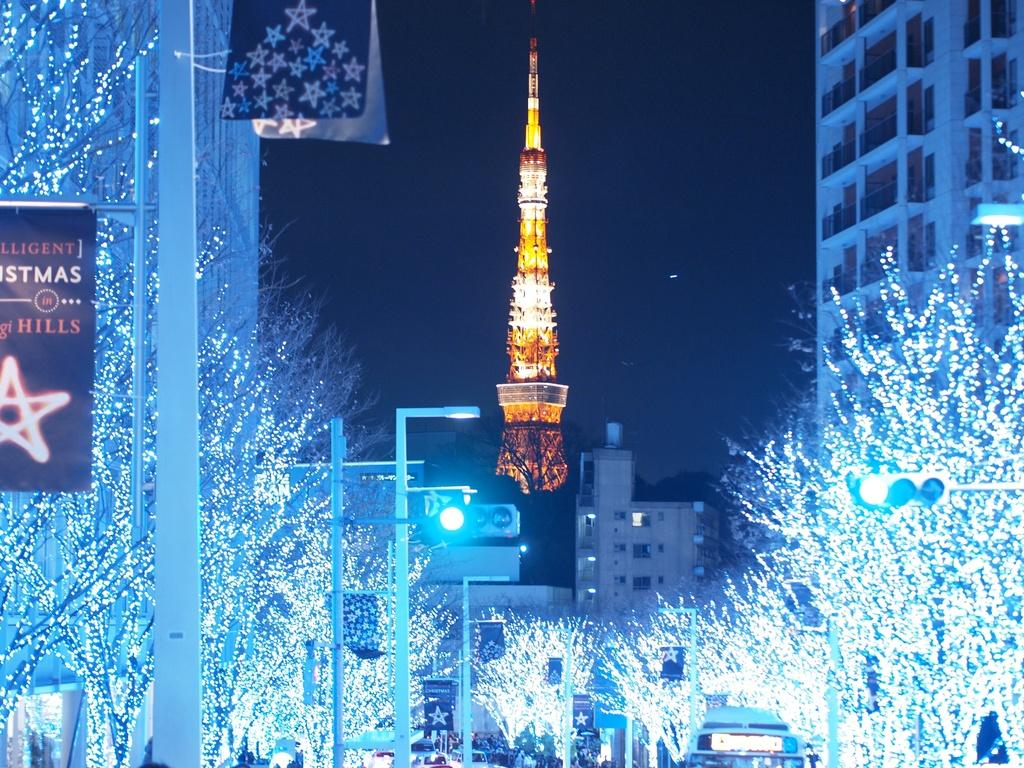What type of lights can be seen on the trees in the image? There are lights on the trees in the image. What structures are visible in the image? There are buildings, a tower, and poles with banners in the image. What type of illumination is present in the image? Street lights and lights on the tower are visible in the image. What type of traffic control devices are present in the image? Traffic lights are present in the image. What can be seen in the background of the image? The sky is visible in the background of the image. What type of cake is being served at the vegetable stand in the image? There is no cake or vegetable stand present in the image. How many legs does the tower have in the image? The tower in the image is a structure and does not have legs. 